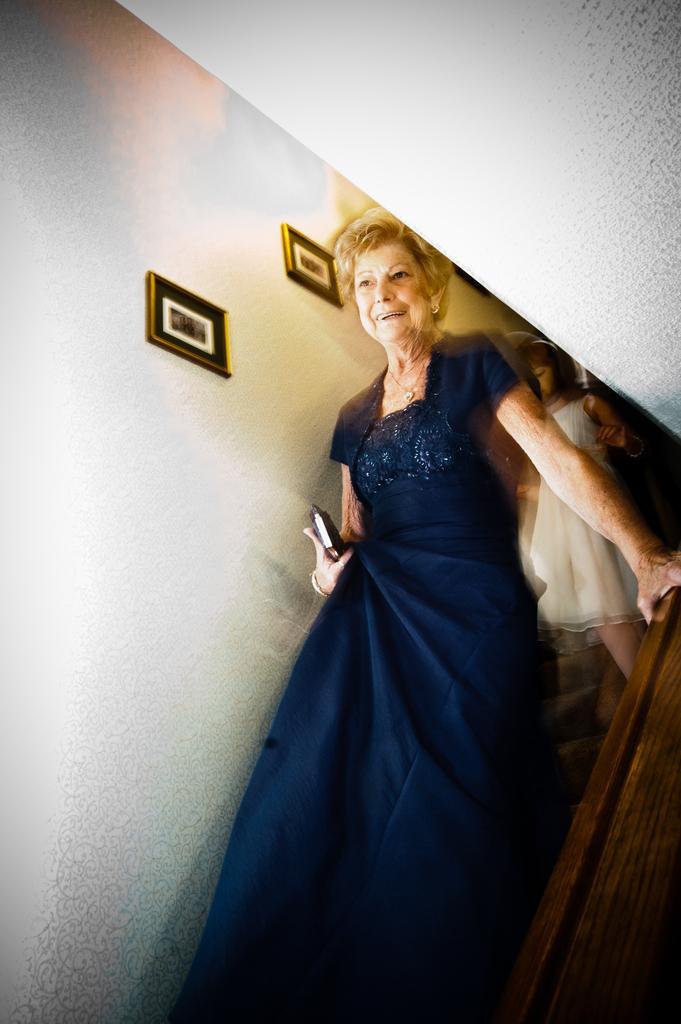Please provide a concise description of this image. In this image, we can see a lady and a kid walking down the steps. There is a wall with some photos on it. 